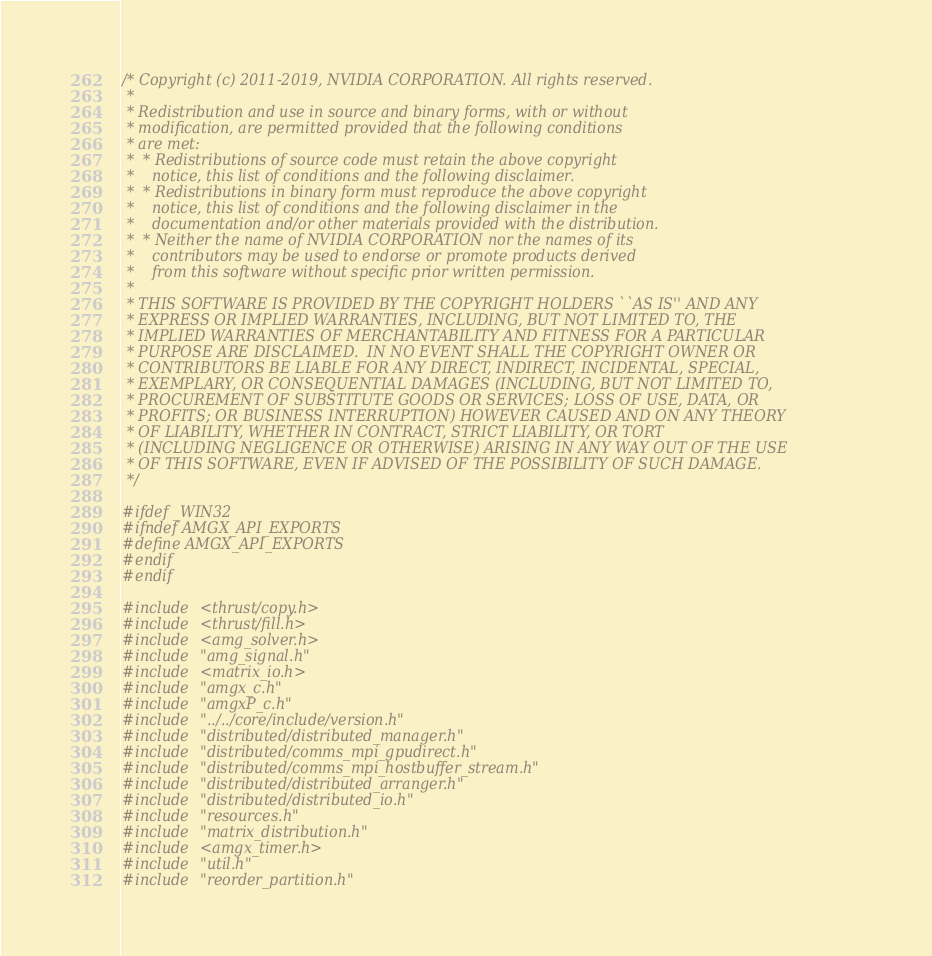Convert code to text. <code><loc_0><loc_0><loc_500><loc_500><_Cuda_>/* Copyright (c) 2011-2019, NVIDIA CORPORATION. All rights reserved.
 *
 * Redistribution and use in source and binary forms, with or without
 * modification, are permitted provided that the following conditions
 * are met:
 *  * Redistributions of source code must retain the above copyright
 *    notice, this list of conditions and the following disclaimer.
 *  * Redistributions in binary form must reproduce the above copyright
 *    notice, this list of conditions and the following disclaimer in the
 *    documentation and/or other materials provided with the distribution.
 *  * Neither the name of NVIDIA CORPORATION nor the names of its
 *    contributors may be used to endorse or promote products derived
 *    from this software without specific prior written permission.
 *
 * THIS SOFTWARE IS PROVIDED BY THE COPYRIGHT HOLDERS ``AS IS'' AND ANY
 * EXPRESS OR IMPLIED WARRANTIES, INCLUDING, BUT NOT LIMITED TO, THE
 * IMPLIED WARRANTIES OF MERCHANTABILITY AND FITNESS FOR A PARTICULAR
 * PURPOSE ARE DISCLAIMED.  IN NO EVENT SHALL THE COPYRIGHT OWNER OR
 * CONTRIBUTORS BE LIABLE FOR ANY DIRECT, INDIRECT, INCIDENTAL, SPECIAL,
 * EXEMPLARY, OR CONSEQUENTIAL DAMAGES (INCLUDING, BUT NOT LIMITED TO,
 * PROCUREMENT OF SUBSTITUTE GOODS OR SERVICES; LOSS OF USE, DATA, OR
 * PROFITS; OR BUSINESS INTERRUPTION) HOWEVER CAUSED AND ON ANY THEORY
 * OF LIABILITY, WHETHER IN CONTRACT, STRICT LIABILITY, OR TORT
 * (INCLUDING NEGLIGENCE OR OTHERWISE) ARISING IN ANY WAY OUT OF THE USE
 * OF THIS SOFTWARE, EVEN IF ADVISED OF THE POSSIBILITY OF SUCH DAMAGE.
 */

#ifdef _WIN32
#ifndef AMGX_API_EXPORTS
#define AMGX_API_EXPORTS
#endif
#endif

#include <thrust/copy.h>
#include <thrust/fill.h>
#include <amg_solver.h>
#include "amg_signal.h"
#include <matrix_io.h>
#include "amgx_c.h"
#include "amgxP_c.h"
#include "../../core/include/version.h"
#include "distributed/distributed_manager.h"
#include "distributed/comms_mpi_gpudirect.h"
#include "distributed/comms_mpi_hostbuffer_stream.h"
#include "distributed/distributed_arranger.h"
#include "distributed/distributed_io.h"
#include "resources.h"
#include "matrix_distribution.h"
#include <amgx_timer.h>
#include "util.h"
#include "reorder_partition.h"</code> 